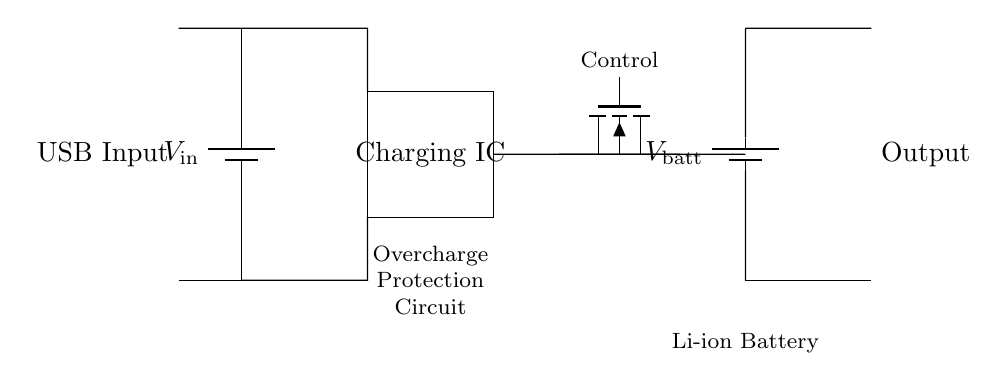What is the input voltage in this circuit? The input voltage is represented as V_in in the circuit diagram, typically denoting the voltage supplied through the USB input. This component is connected to the top of the circuit where the USB input is shown.
Answer: V_in What type of battery is used in this circuit? The circuit diagram specifies a lithium-ion battery, indicated by the labeling of the battery component as V_batt. This suggests the circuit is designed to charge a lithium-ion battery effectively.
Answer: Lithium-ion What is the purpose of the Charging IC? The Charging IC's role is to manage the charging process of the battery, ensuring that the battery is charged efficiently and safely. It prevents issues such as overcharging which can damage the battery.
Answer: Manage charging What could happen if the overcharge protection circuit fails? If the overcharge protection circuit fails, the battery could be charged beyond its safe limit, leading to overheating, swelling, or even rupture, which can pose safety hazards. Therefore, the protection mechanism is crucial.
Answer: Overheating How many main components are visible in this circuit? The circuit clearly shows several components: the battery, USB input, Charging IC, and the MOSFET for overcharge protection. Counting all identifiable parts leads to the conclusion that four main components are present.
Answer: Four 